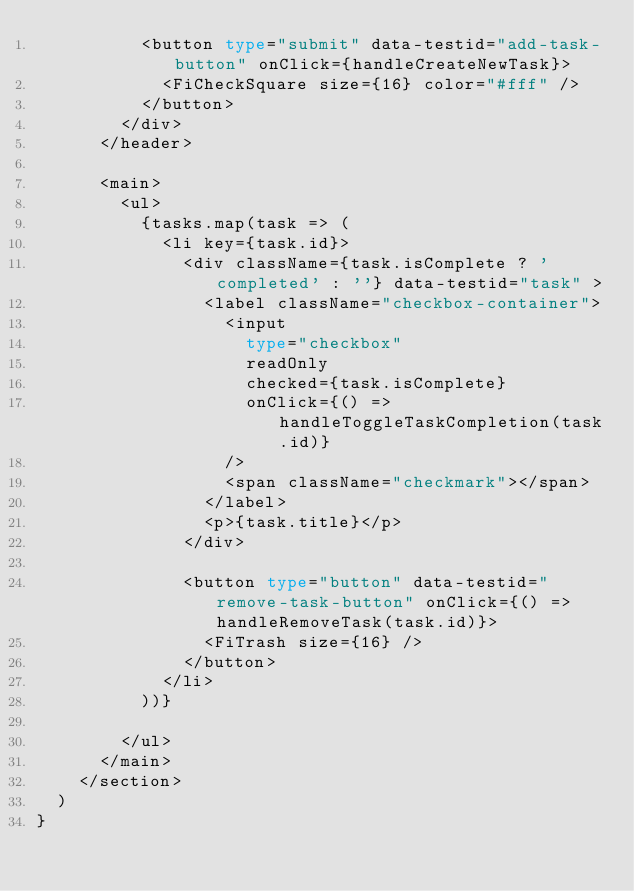<code> <loc_0><loc_0><loc_500><loc_500><_TypeScript_>          <button type="submit" data-testid="add-task-button" onClick={handleCreateNewTask}>
            <FiCheckSquare size={16} color="#fff" />
          </button>
        </div>
      </header>

      <main>
        <ul>
          {tasks.map(task => (
            <li key={task.id}>
              <div className={task.isComplete ? 'completed' : ''} data-testid="task" >
                <label className="checkbox-container">
                  <input
                    type="checkbox"
                    readOnly
                    checked={task.isComplete}
                    onClick={() => handleToggleTaskCompletion(task.id)}
                  />
                  <span className="checkmark"></span>
                </label>
                <p>{task.title}</p>
              </div>

              <button type="button" data-testid="remove-task-button" onClick={() => handleRemoveTask(task.id)}>
                <FiTrash size={16} />
              </button>
            </li>
          ))}

        </ul>
      </main>
    </section>
  )
}</code> 